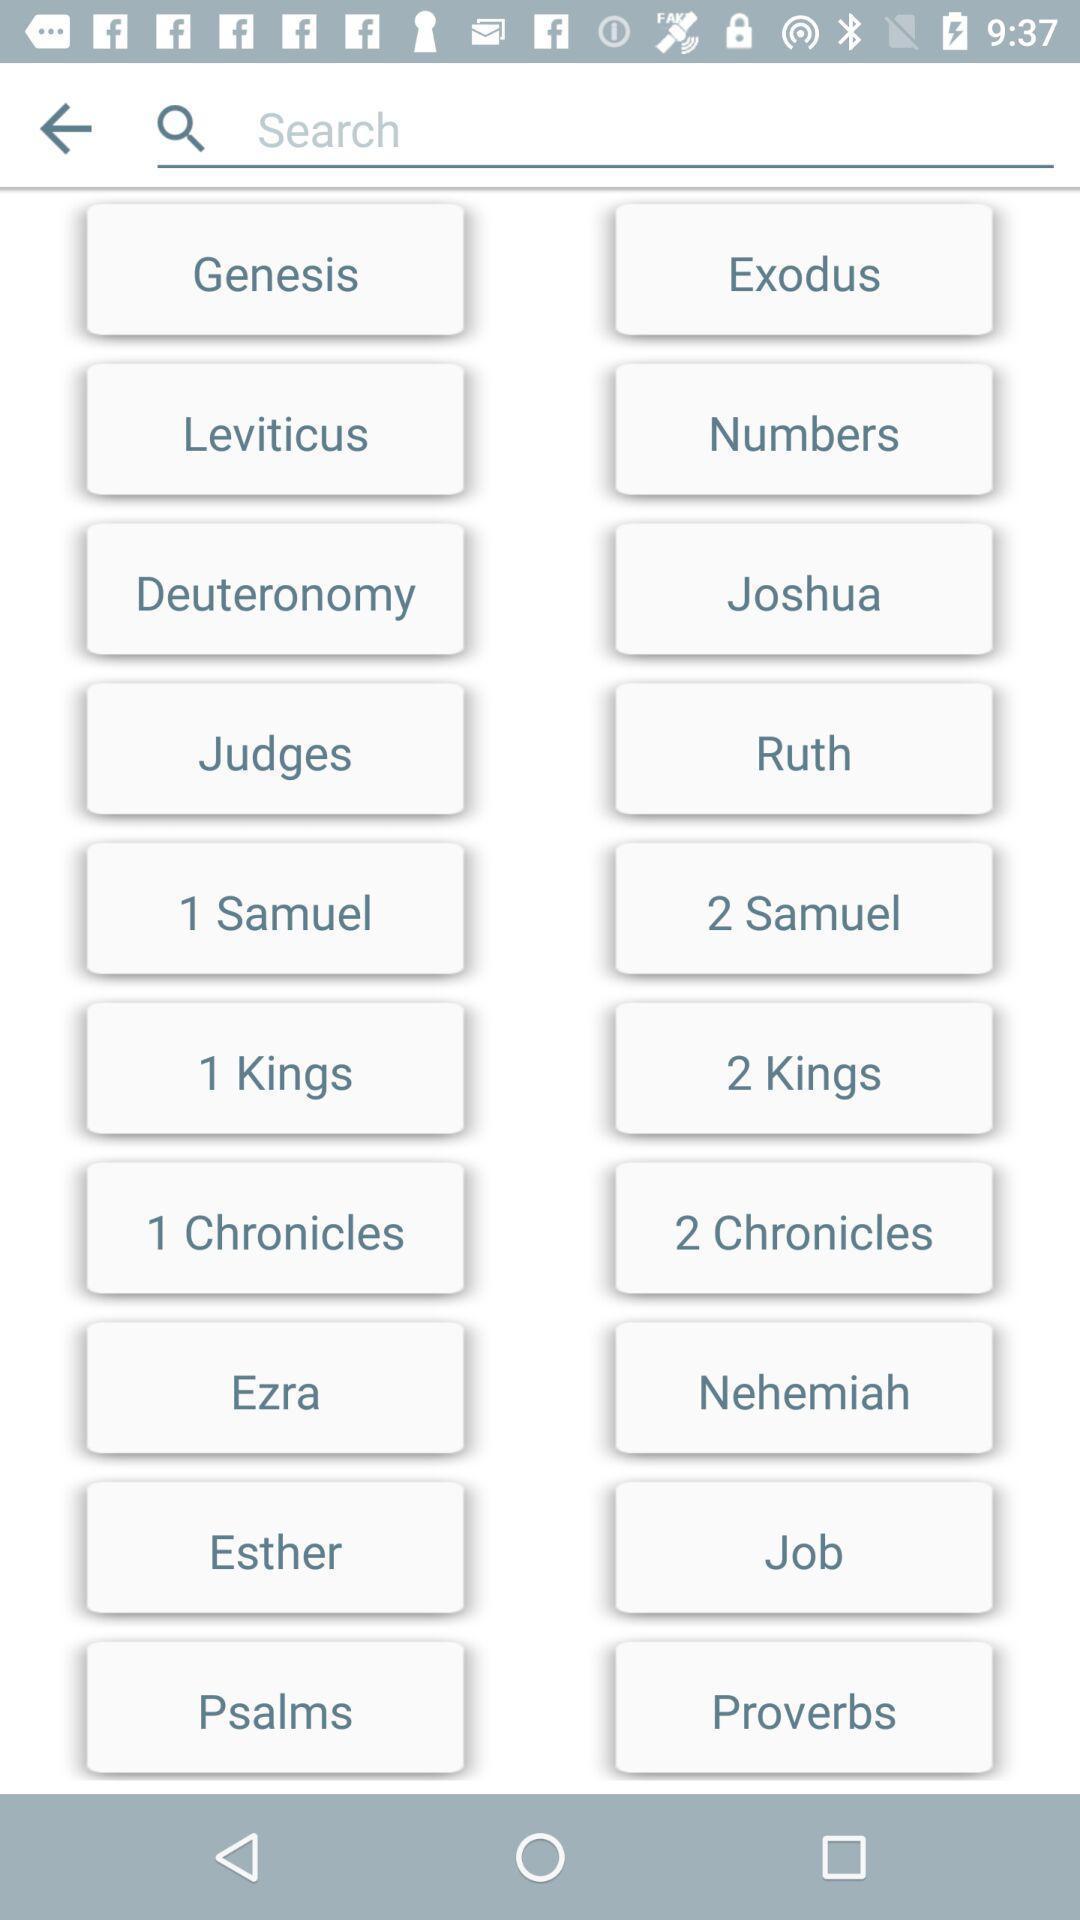Summarize the information in this screenshot. Search page of a religious book. 